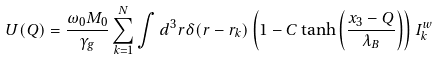Convert formula to latex. <formula><loc_0><loc_0><loc_500><loc_500>U ( Q ) = \frac { \omega _ { 0 } M _ { 0 } } { \gamma _ { g } } \sum _ { k = 1 } ^ { N } \int d ^ { 3 } r \delta ( { r } - { r } _ { k } ) \left ( 1 - C \tanh \left ( \frac { x _ { 3 } - Q } { \lambda _ { B } } \right ) \right ) I _ { k } ^ { w }</formula> 